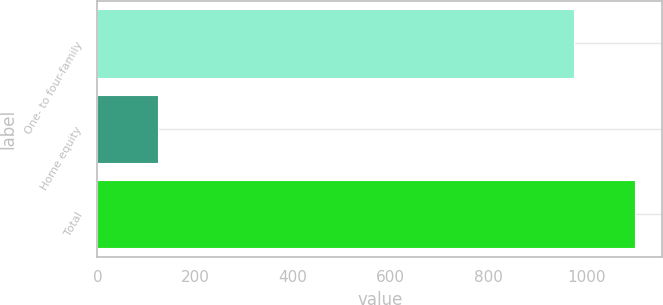Convert chart to OTSL. <chart><loc_0><loc_0><loc_500><loc_500><bar_chart><fcel>One- to four-family<fcel>Home equity<fcel>Total<nl><fcel>976<fcel>124.1<fcel>1100.1<nl></chart> 